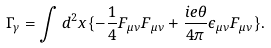<formula> <loc_0><loc_0><loc_500><loc_500>\Gamma _ { \gamma } = \int d ^ { 2 } x \{ - \frac { 1 } { 4 } F _ { \mu \nu } F _ { \mu \nu } + \frac { i e \theta } { 4 \pi } \epsilon _ { \mu \nu } F _ { \mu \nu } \} .</formula> 